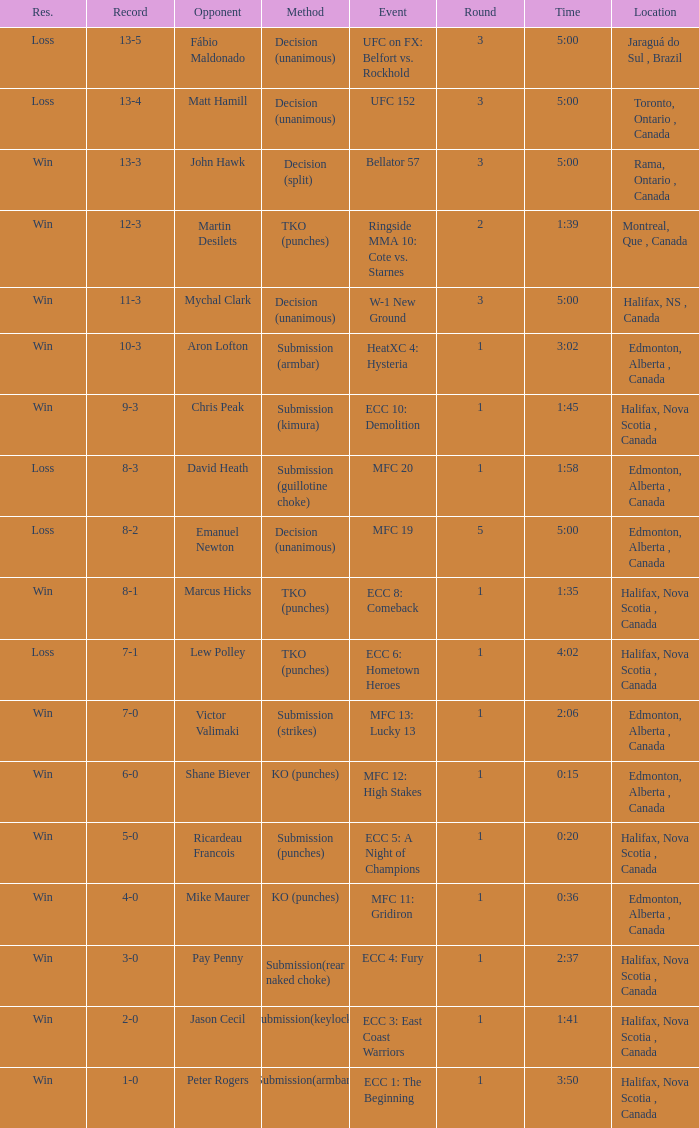What is the method of the match with 1 round and a time of 1:58? Submission (guillotine choke). 